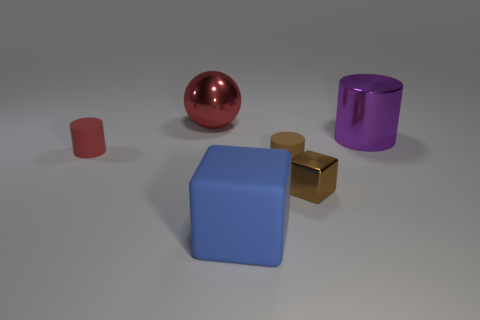How many other things are the same shape as the purple object?
Your answer should be compact. 2. There is a brown object that is made of the same material as the blue thing; what is its size?
Make the answer very short. Small. What number of purple cylinders have the same size as the blue thing?
Provide a succinct answer. 1. There is a cylinder that is the same color as the tiny block; what size is it?
Keep it short and to the point. Small. There is a matte cylinder to the right of the metal thing behind the purple metallic cylinder; what is its color?
Keep it short and to the point. Brown. Is there another big ball of the same color as the ball?
Provide a short and direct response. No. What color is the cylinder that is the same size as the blue cube?
Offer a very short reply. Purple. Do the large thing that is in front of the small metallic cube and the big red object have the same material?
Provide a succinct answer. No. There is a small cylinder on the right side of the large metallic object that is to the left of the purple thing; is there a red shiny ball on the right side of it?
Give a very brief answer. No. Does the thing in front of the tiny brown metal block have the same shape as the large red thing?
Provide a short and direct response. No. 